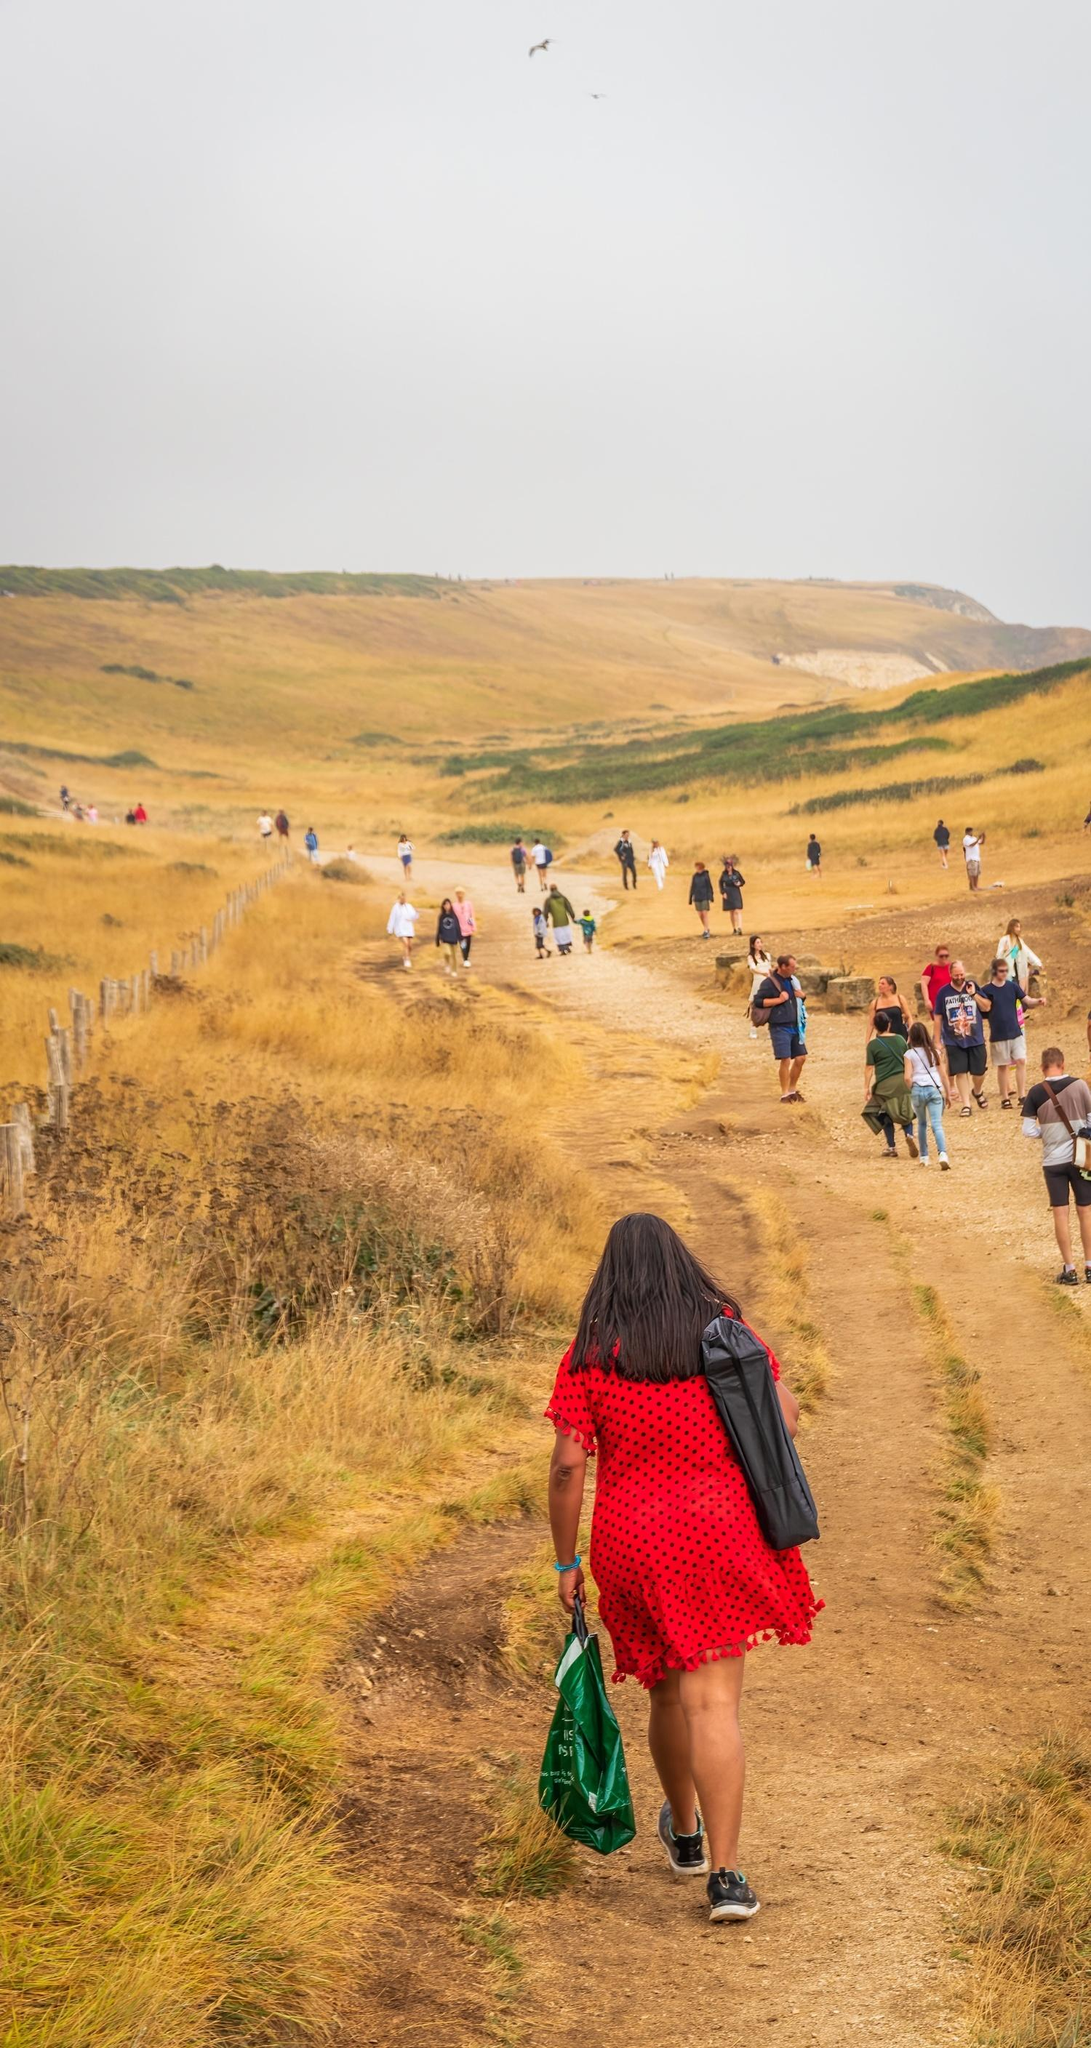Imagine the group encounters an old traveler who shares a legend about this path. What might the legend be? As the group meanders along the dirt path, they come across an old traveler, his weathered face an intricate tapestry of countless tales. With a voice as ancient as the hills, he shares the Legend of the Eternal Path.

Long ago, the path was said to be a gateway between worlds, walked by spirits and guardians of nature. It was believed that at a particular time each year, during the twilight of the autumn equinox, the path would glow with an ethereal light, and those who walked it would be granted glimpses of their true destiny.

The traveler speaks of a hidden spring, deep within the hills, where the waters could reveal one’s heart's desire or offer healing to those who drink from it. He warns them that the path carries the echoes of those who sought its secrets before, and while the journey might offer enlightenment, it also tests the courage and virtue of its travelers.

The legend concludes with a promise: those who tread the Eternal Path with pure intentions might find a way to align their destiny with the ancient forces of nature, becoming part of the timeless story woven into the very fabric of the land. 